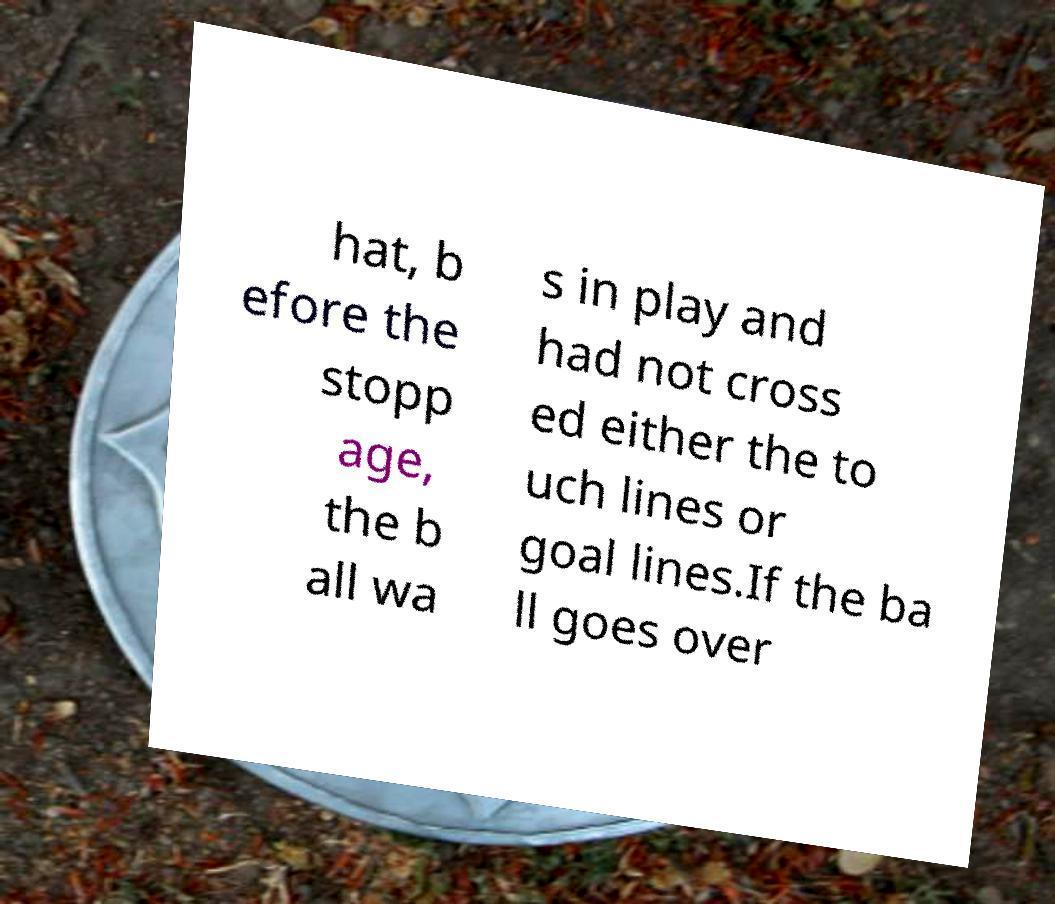For documentation purposes, I need the text within this image transcribed. Could you provide that? hat, b efore the stopp age, the b all wa s in play and had not cross ed either the to uch lines or goal lines.If the ba ll goes over 